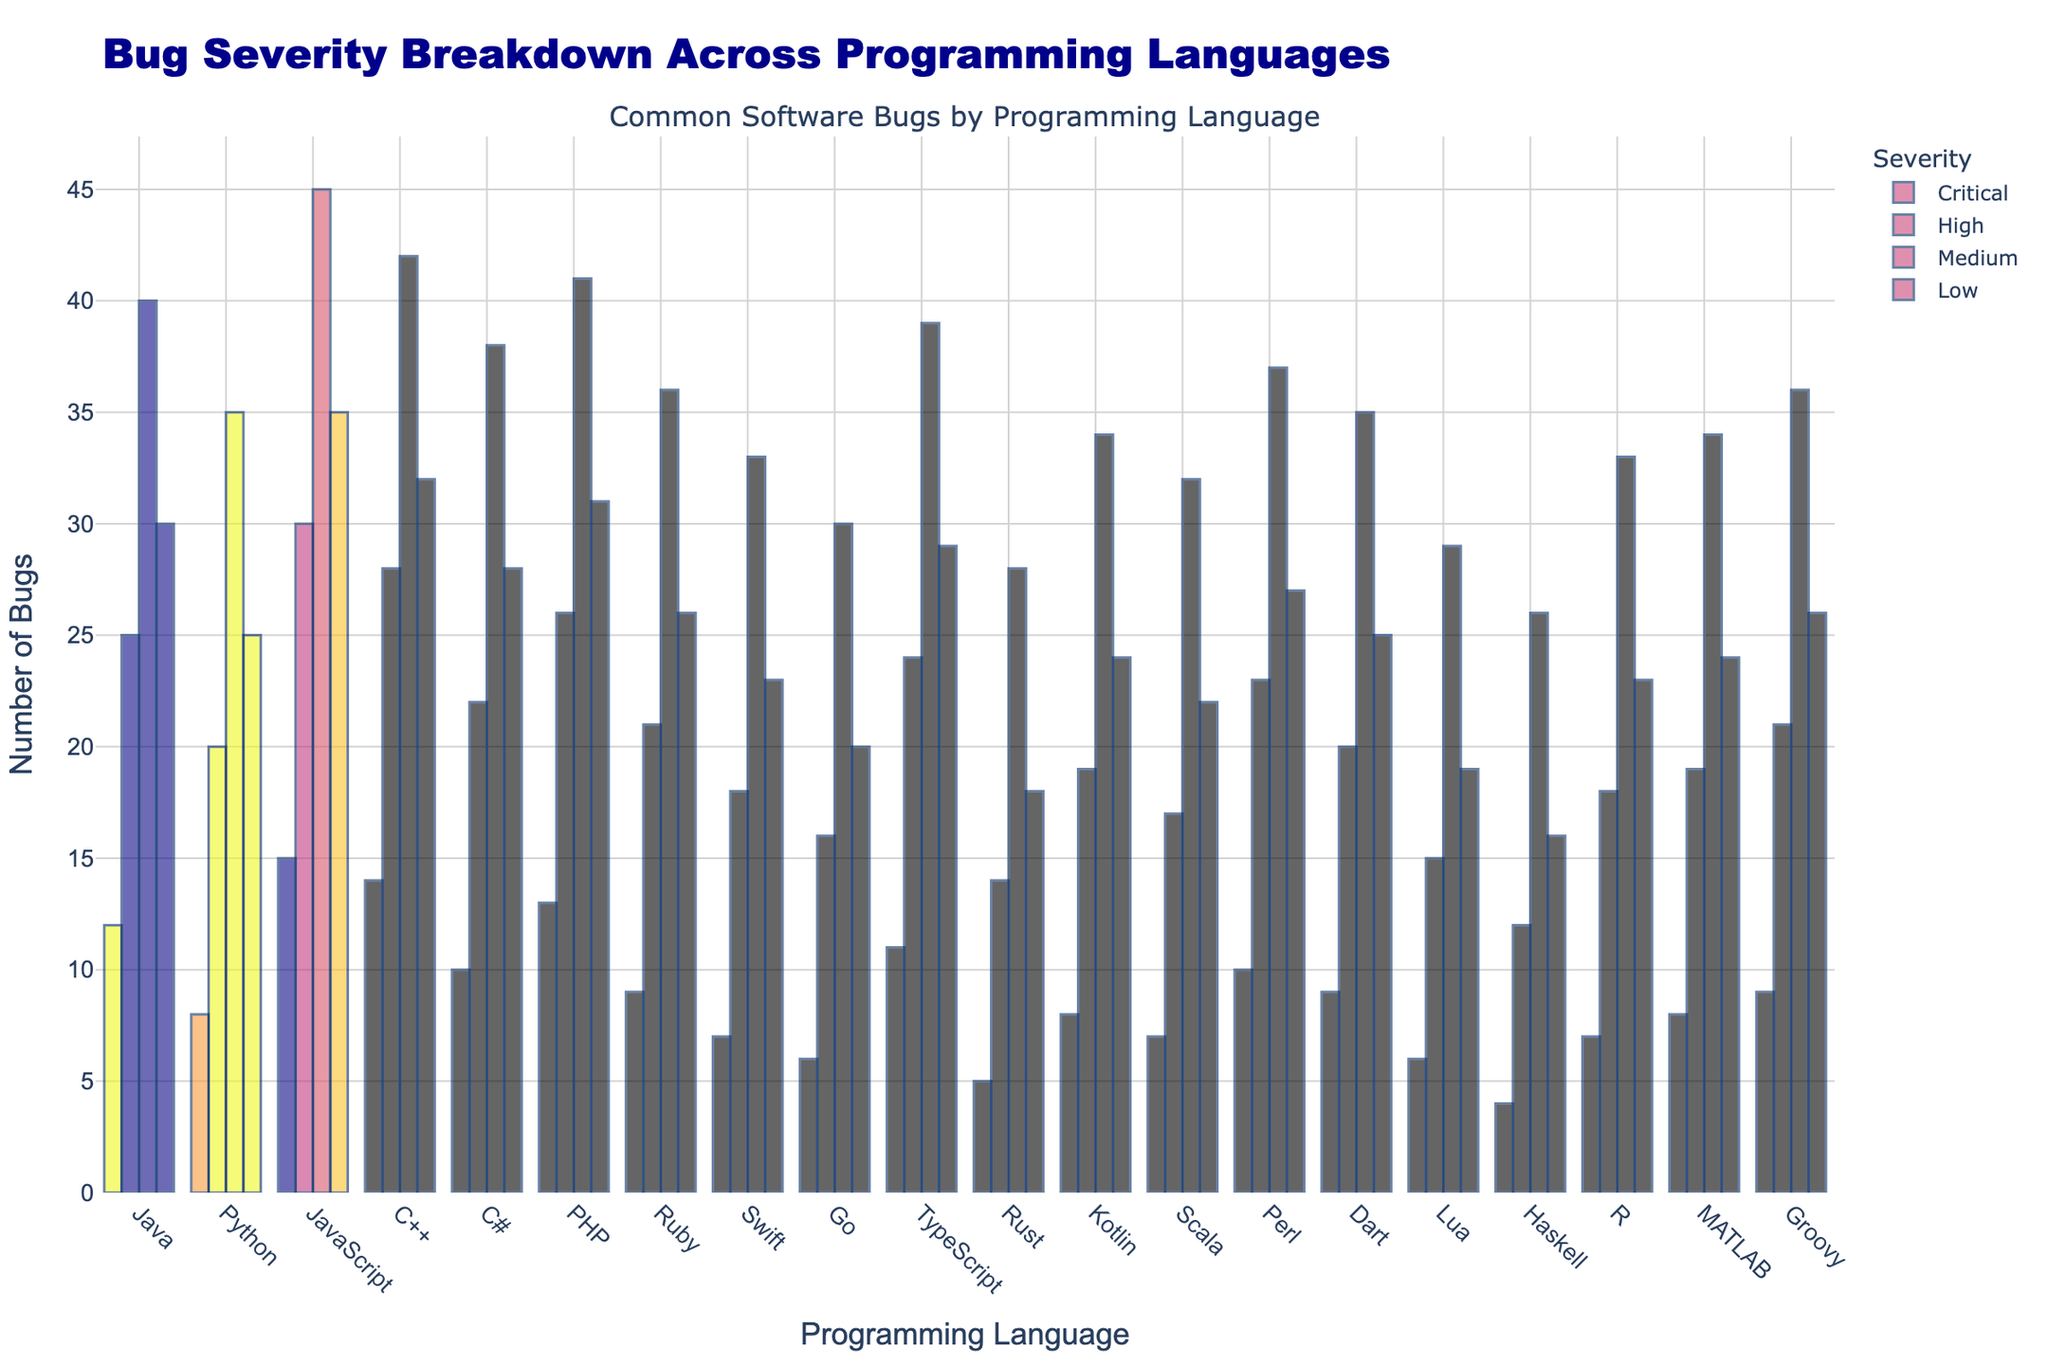What programming language has the highest number of High severity bugs? By examining the heights of the bars representing High severity bugs, we see that JavaScript has the highest bar for this bug severity.
Answer: JavaScript Which language has more Critical bugs, Swift or Perl? By comparing the height of the Critical severity bars for Swift and Perl, we see that Perl's bar is taller than Swift's. Thus, Perl has more Critical bugs.
Answer: Perl What is the total number of Medium severity bugs in Java, Python, and JavaScript combined? Sum the height of the Medium severity bars for Java, Python, and JavaScript: Java (40) + Python (35) + JavaScript (45) = 120
Answer: 120 Between C++ and PHP, which language has fewer Low severity bugs? By comparing the height of the Low severity bars for C++ and PHP, we see that C++ (32) has fewer Low severity bugs than PHP (31).
Answer: PHP How does the number of Critical bugs in Rust compare to Kotlin? Observe the height of the Critical severity bars and find Rust (5) has fewer Critical bugs than Kotlin (8).
Answer: Rust What language has the second-highest number of Critical bugs? The two highest Critical severity bug bars are for JavaScript (15) and C++ (14). The second-highest is C++ (14).
Answer: C++ Which language has a higher total number of bugs, R or MATLAB? Sum the height of all bars (Critical, High, Medium, Low) for R and MATLAB. R: 7+18+33+23=81, MATLAB: 8+19+34+24=85. MATLAB has more.
Answer: MATLAB Calculate the difference in the number of Medium severity bugs between Go and Haskell. Subtract the height of the Medium severity bar for Haskell (26) from Go (30): 30-26=4
Answer: 4 What is the combined number of High severity bugs for Lua and Scala? Add the height of the High severity bars for Lua (15) and Scala (17): 15+17=32
Answer: 32 Between Rust and Haskell, which language has more total bugs of Medium and Low severity combined? Add the heights of the Medium and Low bars for Rust (28+18=46) and Haskell (26+16=42). Rust has more combined Medium and Low severity bugs (46) than Haskell (42).
Answer: Rust 